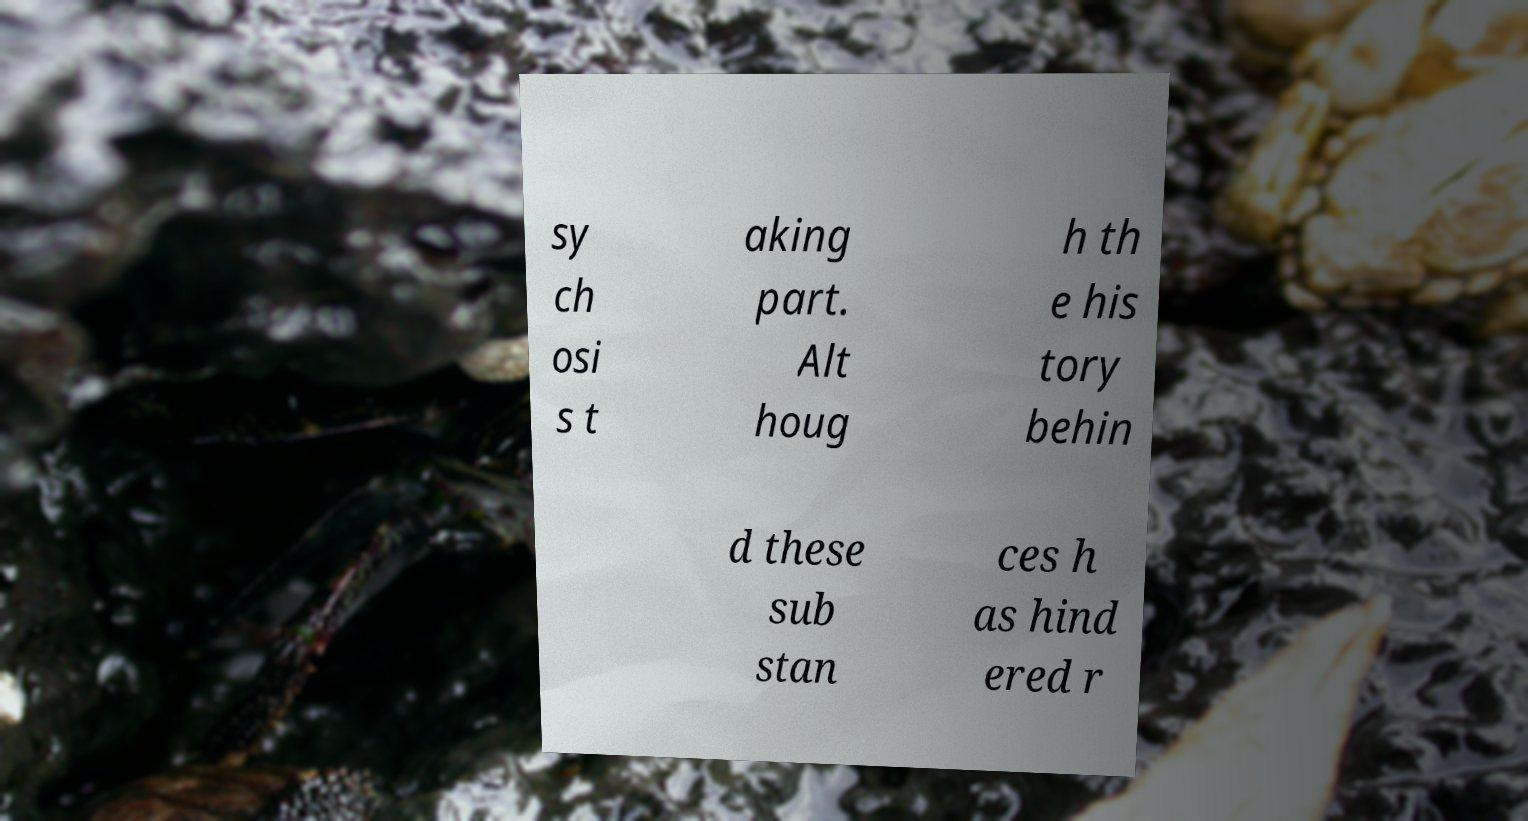Please read and relay the text visible in this image. What does it say? sy ch osi s t aking part. Alt houg h th e his tory behin d these sub stan ces h as hind ered r 